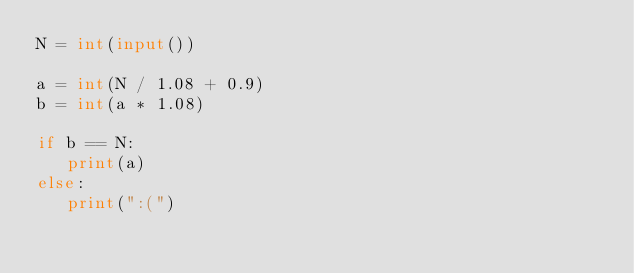<code> <loc_0><loc_0><loc_500><loc_500><_Python_>N = int(input())

a = int(N / 1.08 + 0.9)
b = int(a * 1.08)

if b == N:
   print(a)
else:
   print(":(")</code> 